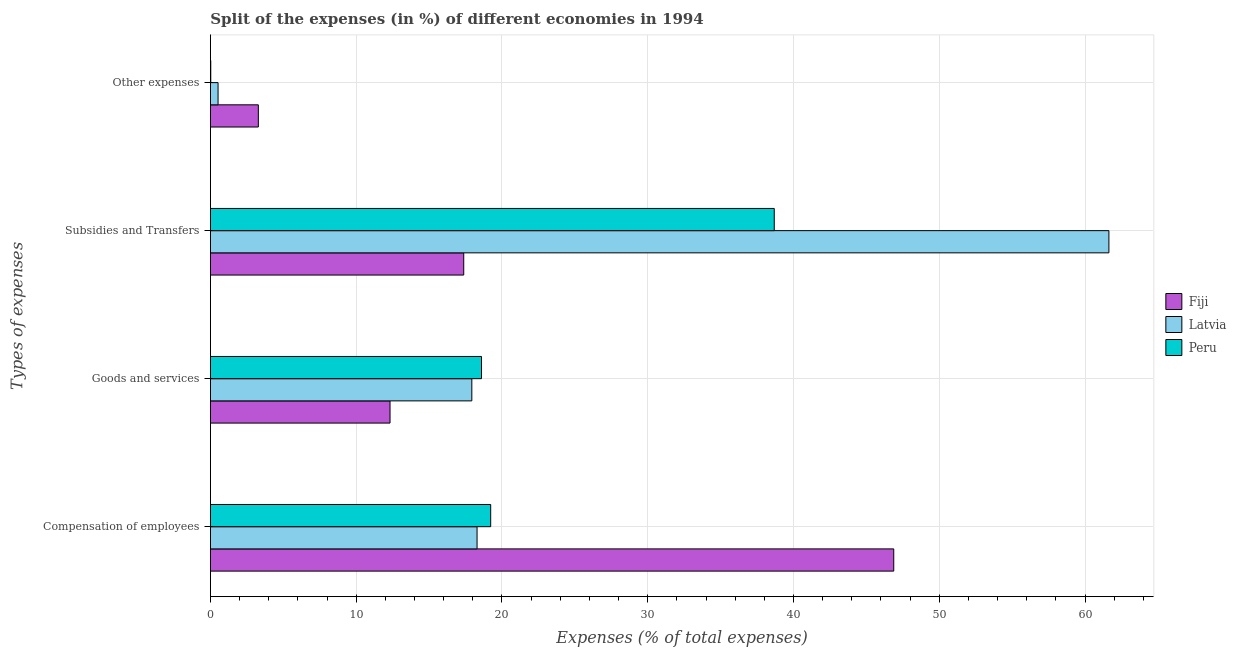How many different coloured bars are there?
Your answer should be compact. 3. Are the number of bars on each tick of the Y-axis equal?
Ensure brevity in your answer.  Yes. How many bars are there on the 3rd tick from the bottom?
Ensure brevity in your answer.  3. What is the label of the 3rd group of bars from the top?
Your answer should be very brief. Goods and services. What is the percentage of amount spent on compensation of employees in Fiji?
Your response must be concise. 46.88. Across all countries, what is the maximum percentage of amount spent on goods and services?
Make the answer very short. 18.6. Across all countries, what is the minimum percentage of amount spent on subsidies?
Your answer should be compact. 17.38. In which country was the percentage of amount spent on subsidies maximum?
Offer a terse response. Latvia. In which country was the percentage of amount spent on subsidies minimum?
Offer a terse response. Fiji. What is the total percentage of amount spent on goods and services in the graph?
Provide a short and direct response. 48.86. What is the difference between the percentage of amount spent on compensation of employees in Latvia and that in Peru?
Your answer should be compact. -0.94. What is the difference between the percentage of amount spent on other expenses in Latvia and the percentage of amount spent on compensation of employees in Fiji?
Ensure brevity in your answer.  -46.35. What is the average percentage of amount spent on goods and services per country?
Give a very brief answer. 16.29. What is the difference between the percentage of amount spent on subsidies and percentage of amount spent on compensation of employees in Peru?
Your answer should be compact. 19.45. What is the ratio of the percentage of amount spent on compensation of employees in Peru to that in Latvia?
Offer a terse response. 1.05. Is the difference between the percentage of amount spent on other expenses in Fiji and Peru greater than the difference between the percentage of amount spent on compensation of employees in Fiji and Peru?
Your answer should be very brief. No. What is the difference between the highest and the second highest percentage of amount spent on compensation of employees?
Provide a succinct answer. 27.65. What is the difference between the highest and the lowest percentage of amount spent on compensation of employees?
Provide a short and direct response. 28.59. In how many countries, is the percentage of amount spent on subsidies greater than the average percentage of amount spent on subsidies taken over all countries?
Keep it short and to the point. 1. Is the sum of the percentage of amount spent on other expenses in Latvia and Peru greater than the maximum percentage of amount spent on goods and services across all countries?
Your answer should be very brief. No. Is it the case that in every country, the sum of the percentage of amount spent on goods and services and percentage of amount spent on other expenses is greater than the sum of percentage of amount spent on compensation of employees and percentage of amount spent on subsidies?
Offer a terse response. No. What does the 2nd bar from the top in Other expenses represents?
Keep it short and to the point. Latvia. What does the 3rd bar from the bottom in Goods and services represents?
Your response must be concise. Peru. How many countries are there in the graph?
Your answer should be compact. 3. Are the values on the major ticks of X-axis written in scientific E-notation?
Offer a terse response. No. Does the graph contain grids?
Provide a succinct answer. Yes. How are the legend labels stacked?
Your response must be concise. Vertical. What is the title of the graph?
Your answer should be compact. Split of the expenses (in %) of different economies in 1994. What is the label or title of the X-axis?
Ensure brevity in your answer.  Expenses (% of total expenses). What is the label or title of the Y-axis?
Your answer should be compact. Types of expenses. What is the Expenses (% of total expenses) of Fiji in Compensation of employees?
Keep it short and to the point. 46.88. What is the Expenses (% of total expenses) in Latvia in Compensation of employees?
Keep it short and to the point. 18.29. What is the Expenses (% of total expenses) in Peru in Compensation of employees?
Give a very brief answer. 19.23. What is the Expenses (% of total expenses) of Fiji in Goods and services?
Your answer should be very brief. 12.32. What is the Expenses (% of total expenses) of Latvia in Goods and services?
Your response must be concise. 17.94. What is the Expenses (% of total expenses) of Peru in Goods and services?
Keep it short and to the point. 18.6. What is the Expenses (% of total expenses) of Fiji in Subsidies and Transfers?
Offer a terse response. 17.38. What is the Expenses (% of total expenses) of Latvia in Subsidies and Transfers?
Provide a short and direct response. 61.64. What is the Expenses (% of total expenses) of Peru in Subsidies and Transfers?
Your answer should be very brief. 38.68. What is the Expenses (% of total expenses) in Fiji in Other expenses?
Provide a succinct answer. 3.29. What is the Expenses (% of total expenses) in Latvia in Other expenses?
Your answer should be compact. 0.53. What is the Expenses (% of total expenses) in Peru in Other expenses?
Offer a very short reply. 0.03. Across all Types of expenses, what is the maximum Expenses (% of total expenses) of Fiji?
Offer a terse response. 46.88. Across all Types of expenses, what is the maximum Expenses (% of total expenses) in Latvia?
Provide a succinct answer. 61.64. Across all Types of expenses, what is the maximum Expenses (% of total expenses) in Peru?
Offer a terse response. 38.68. Across all Types of expenses, what is the minimum Expenses (% of total expenses) of Fiji?
Your answer should be compact. 3.29. Across all Types of expenses, what is the minimum Expenses (% of total expenses) of Latvia?
Offer a very short reply. 0.53. Across all Types of expenses, what is the minimum Expenses (% of total expenses) in Peru?
Offer a terse response. 0.03. What is the total Expenses (% of total expenses) in Fiji in the graph?
Offer a terse response. 79.87. What is the total Expenses (% of total expenses) of Latvia in the graph?
Offer a terse response. 98.4. What is the total Expenses (% of total expenses) in Peru in the graph?
Your answer should be very brief. 76.54. What is the difference between the Expenses (% of total expenses) of Fiji in Compensation of employees and that in Goods and services?
Offer a terse response. 34.56. What is the difference between the Expenses (% of total expenses) in Latvia in Compensation of employees and that in Goods and services?
Offer a very short reply. 0.36. What is the difference between the Expenses (% of total expenses) in Peru in Compensation of employees and that in Goods and services?
Your response must be concise. 0.63. What is the difference between the Expenses (% of total expenses) of Fiji in Compensation of employees and that in Subsidies and Transfers?
Provide a short and direct response. 29.5. What is the difference between the Expenses (% of total expenses) in Latvia in Compensation of employees and that in Subsidies and Transfers?
Provide a succinct answer. -43.35. What is the difference between the Expenses (% of total expenses) in Peru in Compensation of employees and that in Subsidies and Transfers?
Keep it short and to the point. -19.45. What is the difference between the Expenses (% of total expenses) in Fiji in Compensation of employees and that in Other expenses?
Keep it short and to the point. 43.59. What is the difference between the Expenses (% of total expenses) in Latvia in Compensation of employees and that in Other expenses?
Give a very brief answer. 17.77. What is the difference between the Expenses (% of total expenses) in Peru in Compensation of employees and that in Other expenses?
Offer a very short reply. 19.2. What is the difference between the Expenses (% of total expenses) in Fiji in Goods and services and that in Subsidies and Transfers?
Give a very brief answer. -5.06. What is the difference between the Expenses (% of total expenses) in Latvia in Goods and services and that in Subsidies and Transfers?
Offer a terse response. -43.71. What is the difference between the Expenses (% of total expenses) in Peru in Goods and services and that in Subsidies and Transfers?
Provide a short and direct response. -20.08. What is the difference between the Expenses (% of total expenses) of Fiji in Goods and services and that in Other expenses?
Offer a terse response. 9.03. What is the difference between the Expenses (% of total expenses) of Latvia in Goods and services and that in Other expenses?
Offer a very short reply. 17.41. What is the difference between the Expenses (% of total expenses) of Peru in Goods and services and that in Other expenses?
Keep it short and to the point. 18.57. What is the difference between the Expenses (% of total expenses) in Fiji in Subsidies and Transfers and that in Other expenses?
Your answer should be compact. 14.09. What is the difference between the Expenses (% of total expenses) of Latvia in Subsidies and Transfers and that in Other expenses?
Your response must be concise. 61.11. What is the difference between the Expenses (% of total expenses) in Peru in Subsidies and Transfers and that in Other expenses?
Give a very brief answer. 38.66. What is the difference between the Expenses (% of total expenses) of Fiji in Compensation of employees and the Expenses (% of total expenses) of Latvia in Goods and services?
Provide a succinct answer. 28.94. What is the difference between the Expenses (% of total expenses) of Fiji in Compensation of employees and the Expenses (% of total expenses) of Peru in Goods and services?
Make the answer very short. 28.28. What is the difference between the Expenses (% of total expenses) in Latvia in Compensation of employees and the Expenses (% of total expenses) in Peru in Goods and services?
Offer a very short reply. -0.3. What is the difference between the Expenses (% of total expenses) in Fiji in Compensation of employees and the Expenses (% of total expenses) in Latvia in Subsidies and Transfers?
Your answer should be very brief. -14.76. What is the difference between the Expenses (% of total expenses) of Fiji in Compensation of employees and the Expenses (% of total expenses) of Peru in Subsidies and Transfers?
Your response must be concise. 8.2. What is the difference between the Expenses (% of total expenses) of Latvia in Compensation of employees and the Expenses (% of total expenses) of Peru in Subsidies and Transfers?
Keep it short and to the point. -20.39. What is the difference between the Expenses (% of total expenses) of Fiji in Compensation of employees and the Expenses (% of total expenses) of Latvia in Other expenses?
Offer a very short reply. 46.35. What is the difference between the Expenses (% of total expenses) of Fiji in Compensation of employees and the Expenses (% of total expenses) of Peru in Other expenses?
Offer a terse response. 46.85. What is the difference between the Expenses (% of total expenses) of Latvia in Compensation of employees and the Expenses (% of total expenses) of Peru in Other expenses?
Your answer should be very brief. 18.27. What is the difference between the Expenses (% of total expenses) of Fiji in Goods and services and the Expenses (% of total expenses) of Latvia in Subsidies and Transfers?
Offer a terse response. -49.32. What is the difference between the Expenses (% of total expenses) of Fiji in Goods and services and the Expenses (% of total expenses) of Peru in Subsidies and Transfers?
Your response must be concise. -26.36. What is the difference between the Expenses (% of total expenses) in Latvia in Goods and services and the Expenses (% of total expenses) in Peru in Subsidies and Transfers?
Your answer should be compact. -20.75. What is the difference between the Expenses (% of total expenses) in Fiji in Goods and services and the Expenses (% of total expenses) in Latvia in Other expenses?
Ensure brevity in your answer.  11.8. What is the difference between the Expenses (% of total expenses) in Fiji in Goods and services and the Expenses (% of total expenses) in Peru in Other expenses?
Offer a terse response. 12.3. What is the difference between the Expenses (% of total expenses) in Latvia in Goods and services and the Expenses (% of total expenses) in Peru in Other expenses?
Your answer should be compact. 17.91. What is the difference between the Expenses (% of total expenses) of Fiji in Subsidies and Transfers and the Expenses (% of total expenses) of Latvia in Other expenses?
Keep it short and to the point. 16.85. What is the difference between the Expenses (% of total expenses) in Fiji in Subsidies and Transfers and the Expenses (% of total expenses) in Peru in Other expenses?
Make the answer very short. 17.35. What is the difference between the Expenses (% of total expenses) of Latvia in Subsidies and Transfers and the Expenses (% of total expenses) of Peru in Other expenses?
Your answer should be compact. 61.61. What is the average Expenses (% of total expenses) of Fiji per Types of expenses?
Provide a succinct answer. 19.97. What is the average Expenses (% of total expenses) of Latvia per Types of expenses?
Give a very brief answer. 24.6. What is the average Expenses (% of total expenses) in Peru per Types of expenses?
Keep it short and to the point. 19.13. What is the difference between the Expenses (% of total expenses) in Fiji and Expenses (% of total expenses) in Latvia in Compensation of employees?
Provide a succinct answer. 28.59. What is the difference between the Expenses (% of total expenses) of Fiji and Expenses (% of total expenses) of Peru in Compensation of employees?
Provide a succinct answer. 27.65. What is the difference between the Expenses (% of total expenses) of Latvia and Expenses (% of total expenses) of Peru in Compensation of employees?
Provide a succinct answer. -0.94. What is the difference between the Expenses (% of total expenses) of Fiji and Expenses (% of total expenses) of Latvia in Goods and services?
Your answer should be compact. -5.61. What is the difference between the Expenses (% of total expenses) of Fiji and Expenses (% of total expenses) of Peru in Goods and services?
Provide a succinct answer. -6.27. What is the difference between the Expenses (% of total expenses) of Latvia and Expenses (% of total expenses) of Peru in Goods and services?
Your response must be concise. -0.66. What is the difference between the Expenses (% of total expenses) in Fiji and Expenses (% of total expenses) in Latvia in Subsidies and Transfers?
Ensure brevity in your answer.  -44.26. What is the difference between the Expenses (% of total expenses) in Fiji and Expenses (% of total expenses) in Peru in Subsidies and Transfers?
Keep it short and to the point. -21.3. What is the difference between the Expenses (% of total expenses) of Latvia and Expenses (% of total expenses) of Peru in Subsidies and Transfers?
Ensure brevity in your answer.  22.96. What is the difference between the Expenses (% of total expenses) of Fiji and Expenses (% of total expenses) of Latvia in Other expenses?
Make the answer very short. 2.76. What is the difference between the Expenses (% of total expenses) of Fiji and Expenses (% of total expenses) of Peru in Other expenses?
Keep it short and to the point. 3.26. What is the ratio of the Expenses (% of total expenses) of Fiji in Compensation of employees to that in Goods and services?
Your answer should be compact. 3.8. What is the ratio of the Expenses (% of total expenses) of Peru in Compensation of employees to that in Goods and services?
Offer a terse response. 1.03. What is the ratio of the Expenses (% of total expenses) of Fiji in Compensation of employees to that in Subsidies and Transfers?
Offer a very short reply. 2.7. What is the ratio of the Expenses (% of total expenses) of Latvia in Compensation of employees to that in Subsidies and Transfers?
Keep it short and to the point. 0.3. What is the ratio of the Expenses (% of total expenses) in Peru in Compensation of employees to that in Subsidies and Transfers?
Provide a short and direct response. 0.5. What is the ratio of the Expenses (% of total expenses) in Fiji in Compensation of employees to that in Other expenses?
Your response must be concise. 14.25. What is the ratio of the Expenses (% of total expenses) of Latvia in Compensation of employees to that in Other expenses?
Your answer should be compact. 34.76. What is the ratio of the Expenses (% of total expenses) in Peru in Compensation of employees to that in Other expenses?
Give a very brief answer. 731.25. What is the ratio of the Expenses (% of total expenses) of Fiji in Goods and services to that in Subsidies and Transfers?
Keep it short and to the point. 0.71. What is the ratio of the Expenses (% of total expenses) in Latvia in Goods and services to that in Subsidies and Transfers?
Your response must be concise. 0.29. What is the ratio of the Expenses (% of total expenses) of Peru in Goods and services to that in Subsidies and Transfers?
Offer a terse response. 0.48. What is the ratio of the Expenses (% of total expenses) in Fiji in Goods and services to that in Other expenses?
Offer a terse response. 3.75. What is the ratio of the Expenses (% of total expenses) of Latvia in Goods and services to that in Other expenses?
Offer a very short reply. 34.08. What is the ratio of the Expenses (% of total expenses) in Peru in Goods and services to that in Other expenses?
Your response must be concise. 707.25. What is the ratio of the Expenses (% of total expenses) of Fiji in Subsidies and Transfers to that in Other expenses?
Offer a terse response. 5.28. What is the ratio of the Expenses (% of total expenses) in Latvia in Subsidies and Transfers to that in Other expenses?
Keep it short and to the point. 117.13. What is the ratio of the Expenses (% of total expenses) in Peru in Subsidies and Transfers to that in Other expenses?
Ensure brevity in your answer.  1471. What is the difference between the highest and the second highest Expenses (% of total expenses) in Fiji?
Keep it short and to the point. 29.5. What is the difference between the highest and the second highest Expenses (% of total expenses) of Latvia?
Ensure brevity in your answer.  43.35. What is the difference between the highest and the second highest Expenses (% of total expenses) of Peru?
Give a very brief answer. 19.45. What is the difference between the highest and the lowest Expenses (% of total expenses) of Fiji?
Your response must be concise. 43.59. What is the difference between the highest and the lowest Expenses (% of total expenses) of Latvia?
Offer a very short reply. 61.11. What is the difference between the highest and the lowest Expenses (% of total expenses) of Peru?
Make the answer very short. 38.66. 